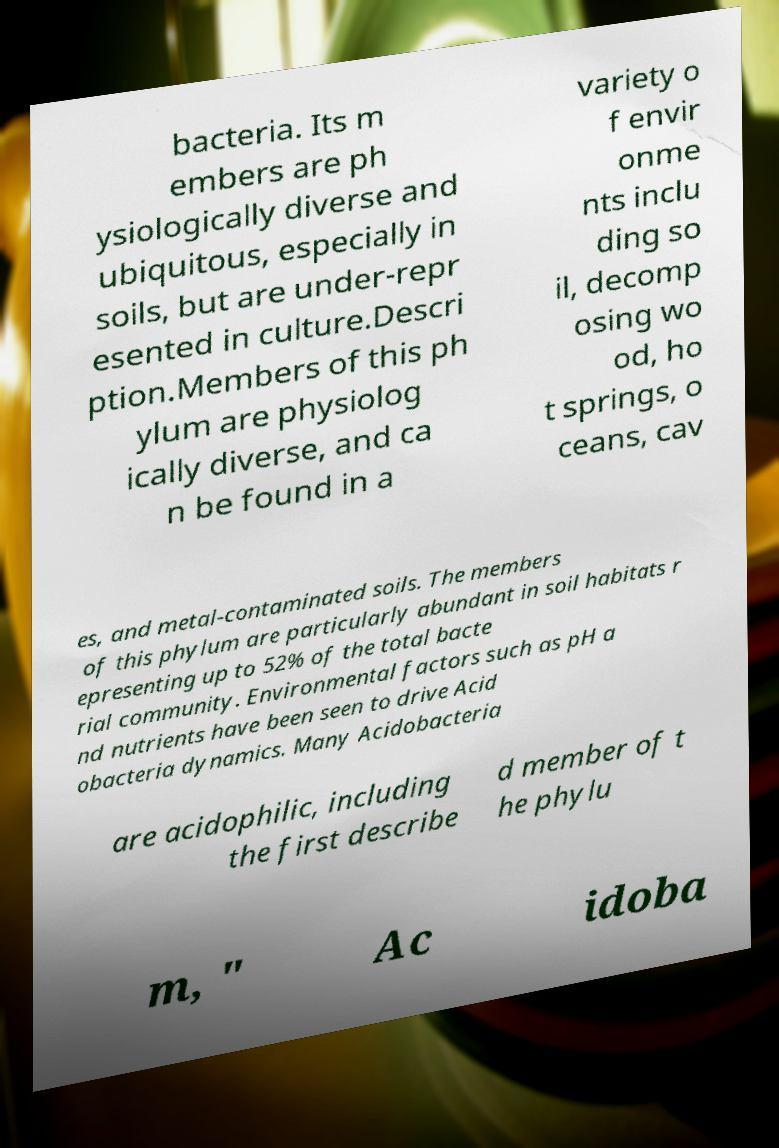For documentation purposes, I need the text within this image transcribed. Could you provide that? bacteria. Its m embers are ph ysiologically diverse and ubiquitous, especially in soils, but are under-repr esented in culture.Descri ption.Members of this ph ylum are physiolog ically diverse, and ca n be found in a variety o f envir onme nts inclu ding so il, decomp osing wo od, ho t springs, o ceans, cav es, and metal-contaminated soils. The members of this phylum are particularly abundant in soil habitats r epresenting up to 52% of the total bacte rial community. Environmental factors such as pH a nd nutrients have been seen to drive Acid obacteria dynamics. Many Acidobacteria are acidophilic, including the first describe d member of t he phylu m, " Ac idoba 